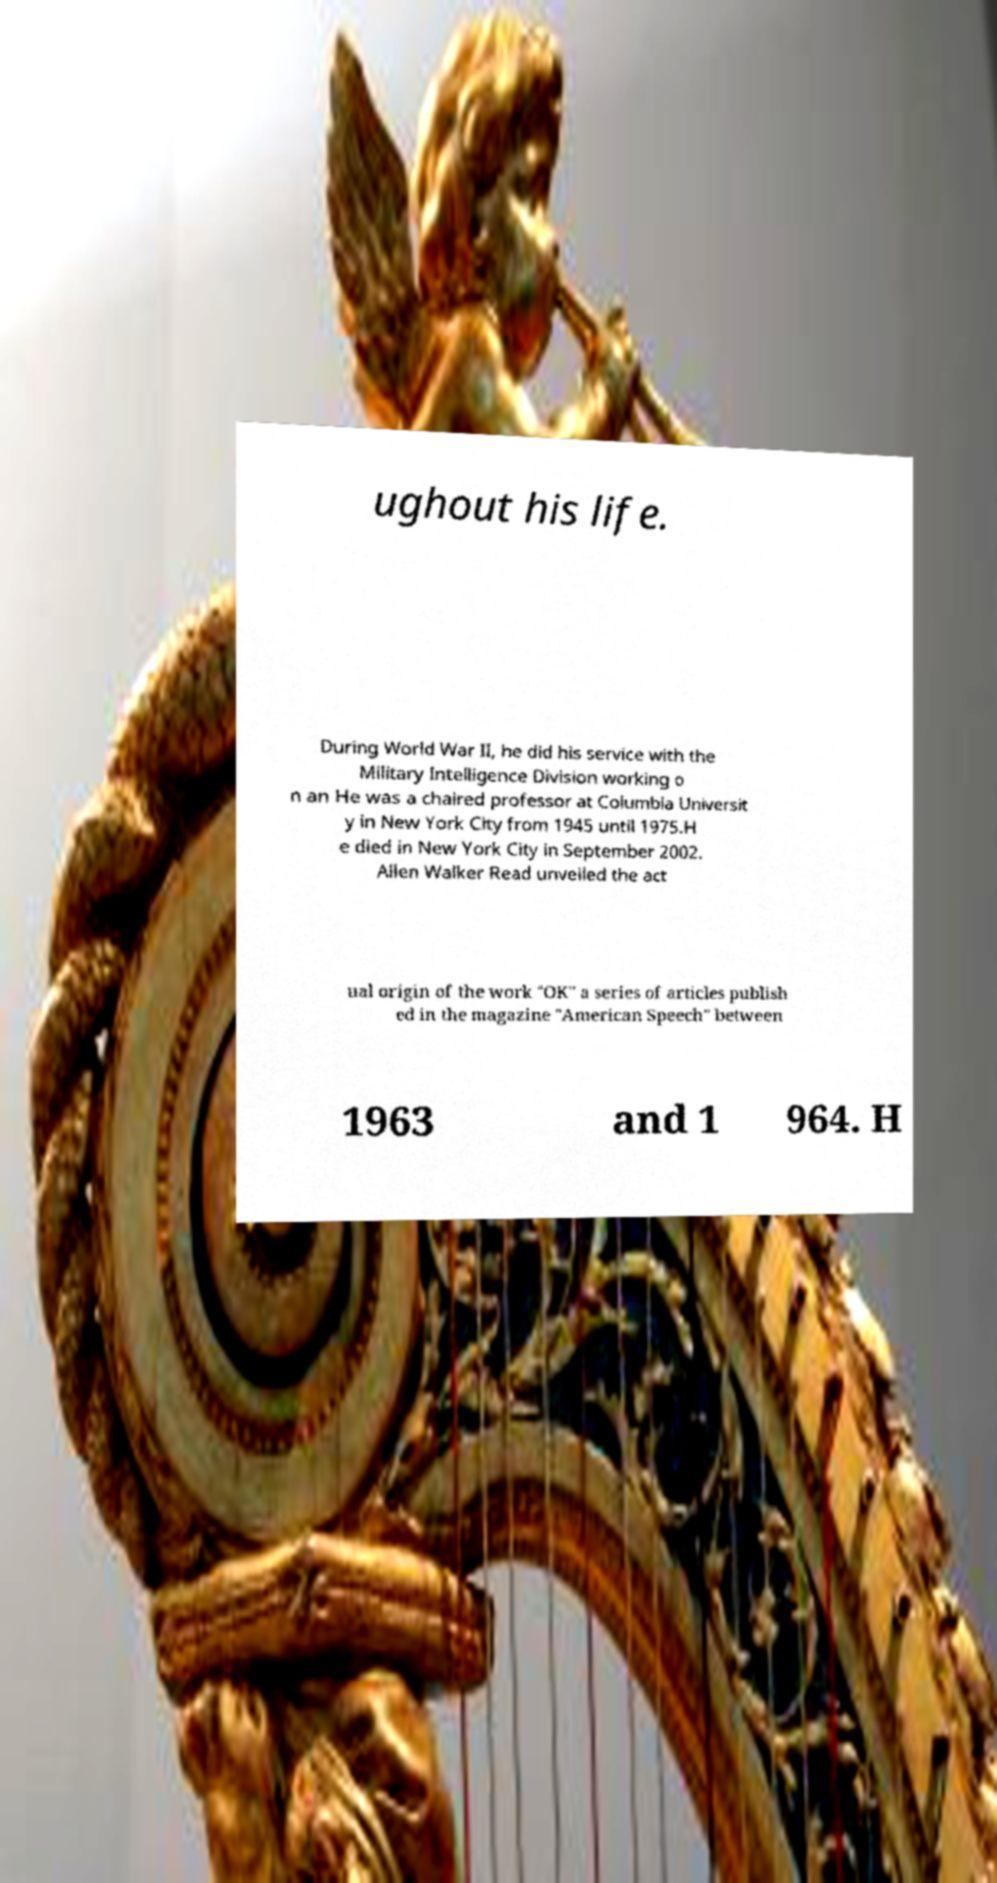Could you extract and type out the text from this image? ughout his life. During World War II, he did his service with the Military Intelligence Division working o n an He was a chaired professor at Columbia Universit y in New York City from 1945 until 1975.H e died in New York City in September 2002. Allen Walker Read unveiled the act ual origin of the work "OK" a series of articles publish ed in the magazine "American Speech" between 1963 and 1 964. H 